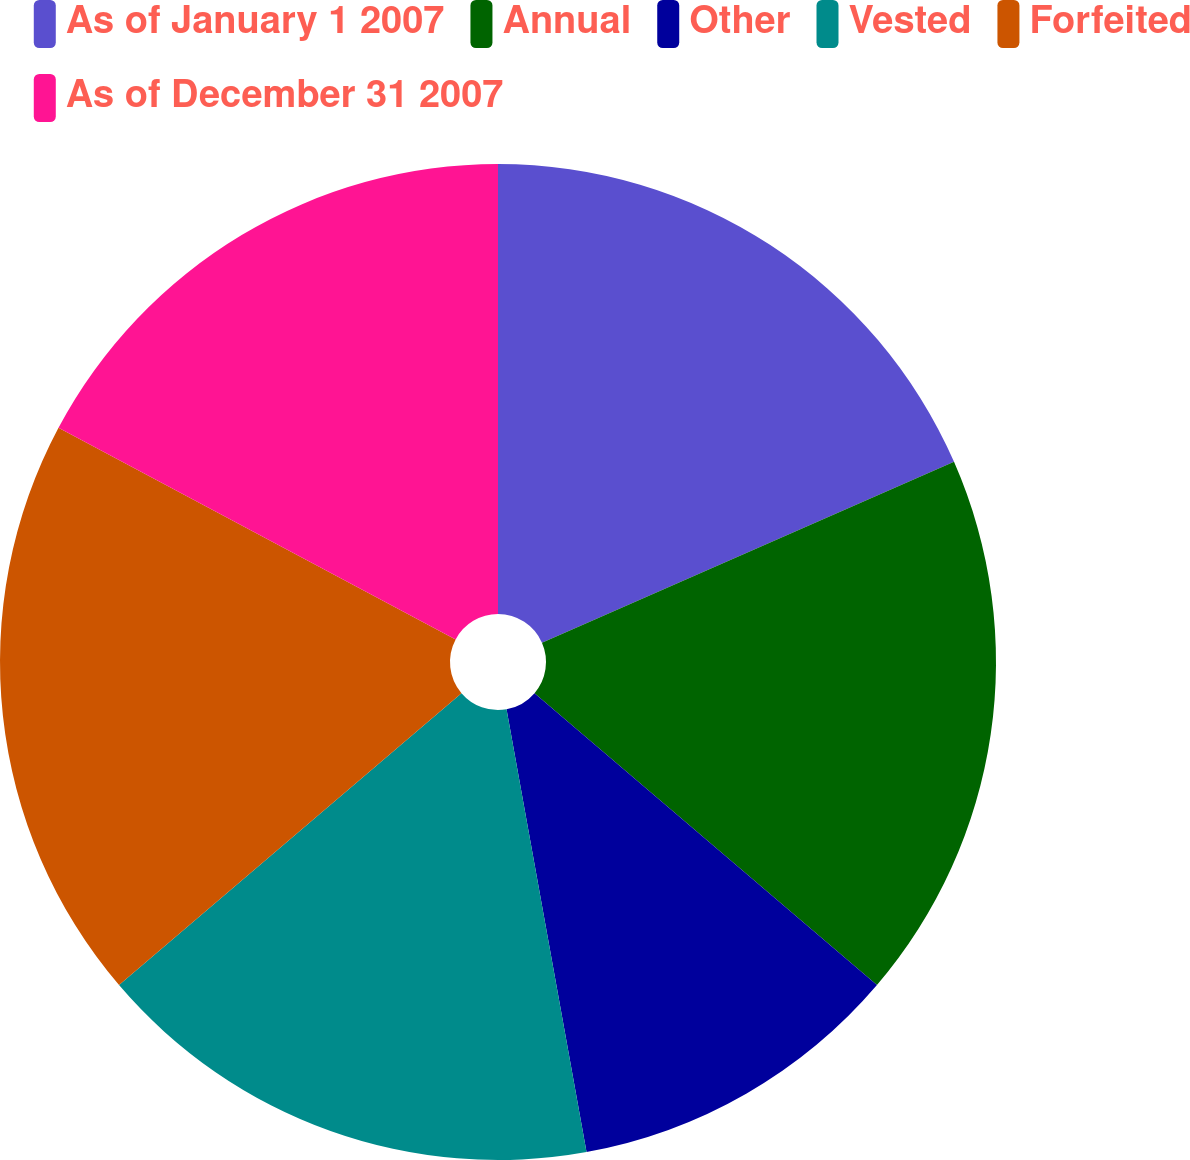Convert chart to OTSL. <chart><loc_0><loc_0><loc_500><loc_500><pie_chart><fcel>As of January 1 2007<fcel>Annual<fcel>Other<fcel>Vested<fcel>Forfeited<fcel>As of December 31 2007<nl><fcel>18.42%<fcel>17.82%<fcel>10.92%<fcel>16.61%<fcel>19.03%<fcel>17.21%<nl></chart> 